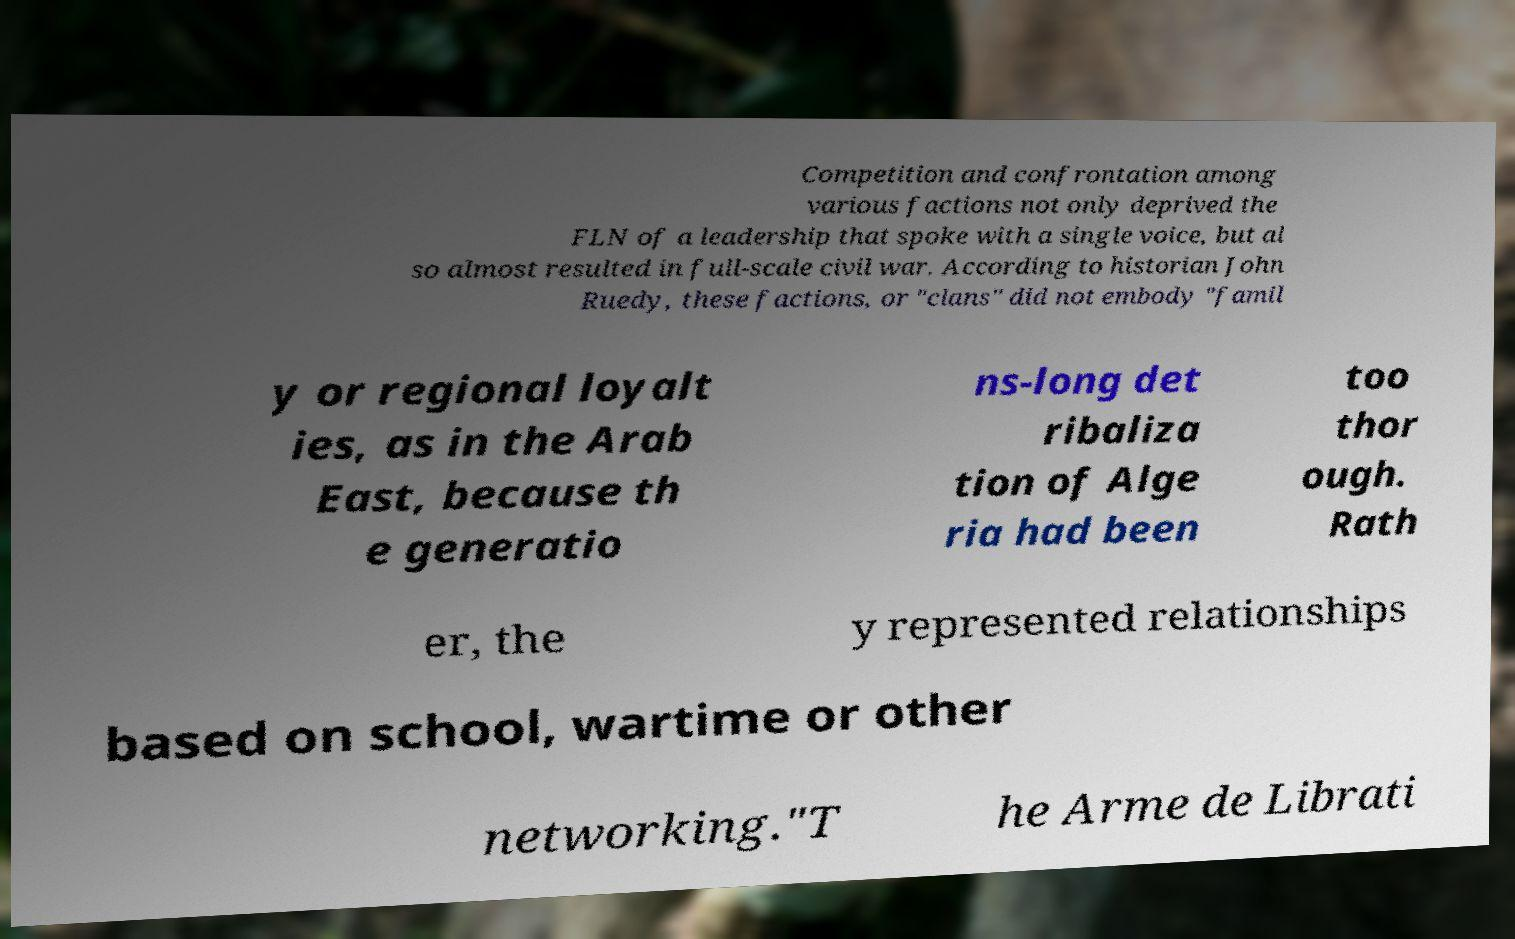I need the written content from this picture converted into text. Can you do that? Competition and confrontation among various factions not only deprived the FLN of a leadership that spoke with a single voice, but al so almost resulted in full-scale civil war. According to historian John Ruedy, these factions, or "clans" did not embody "famil y or regional loyalt ies, as in the Arab East, because th e generatio ns-long det ribaliza tion of Alge ria had been too thor ough. Rath er, the y represented relationships based on school, wartime or other networking."T he Arme de Librati 